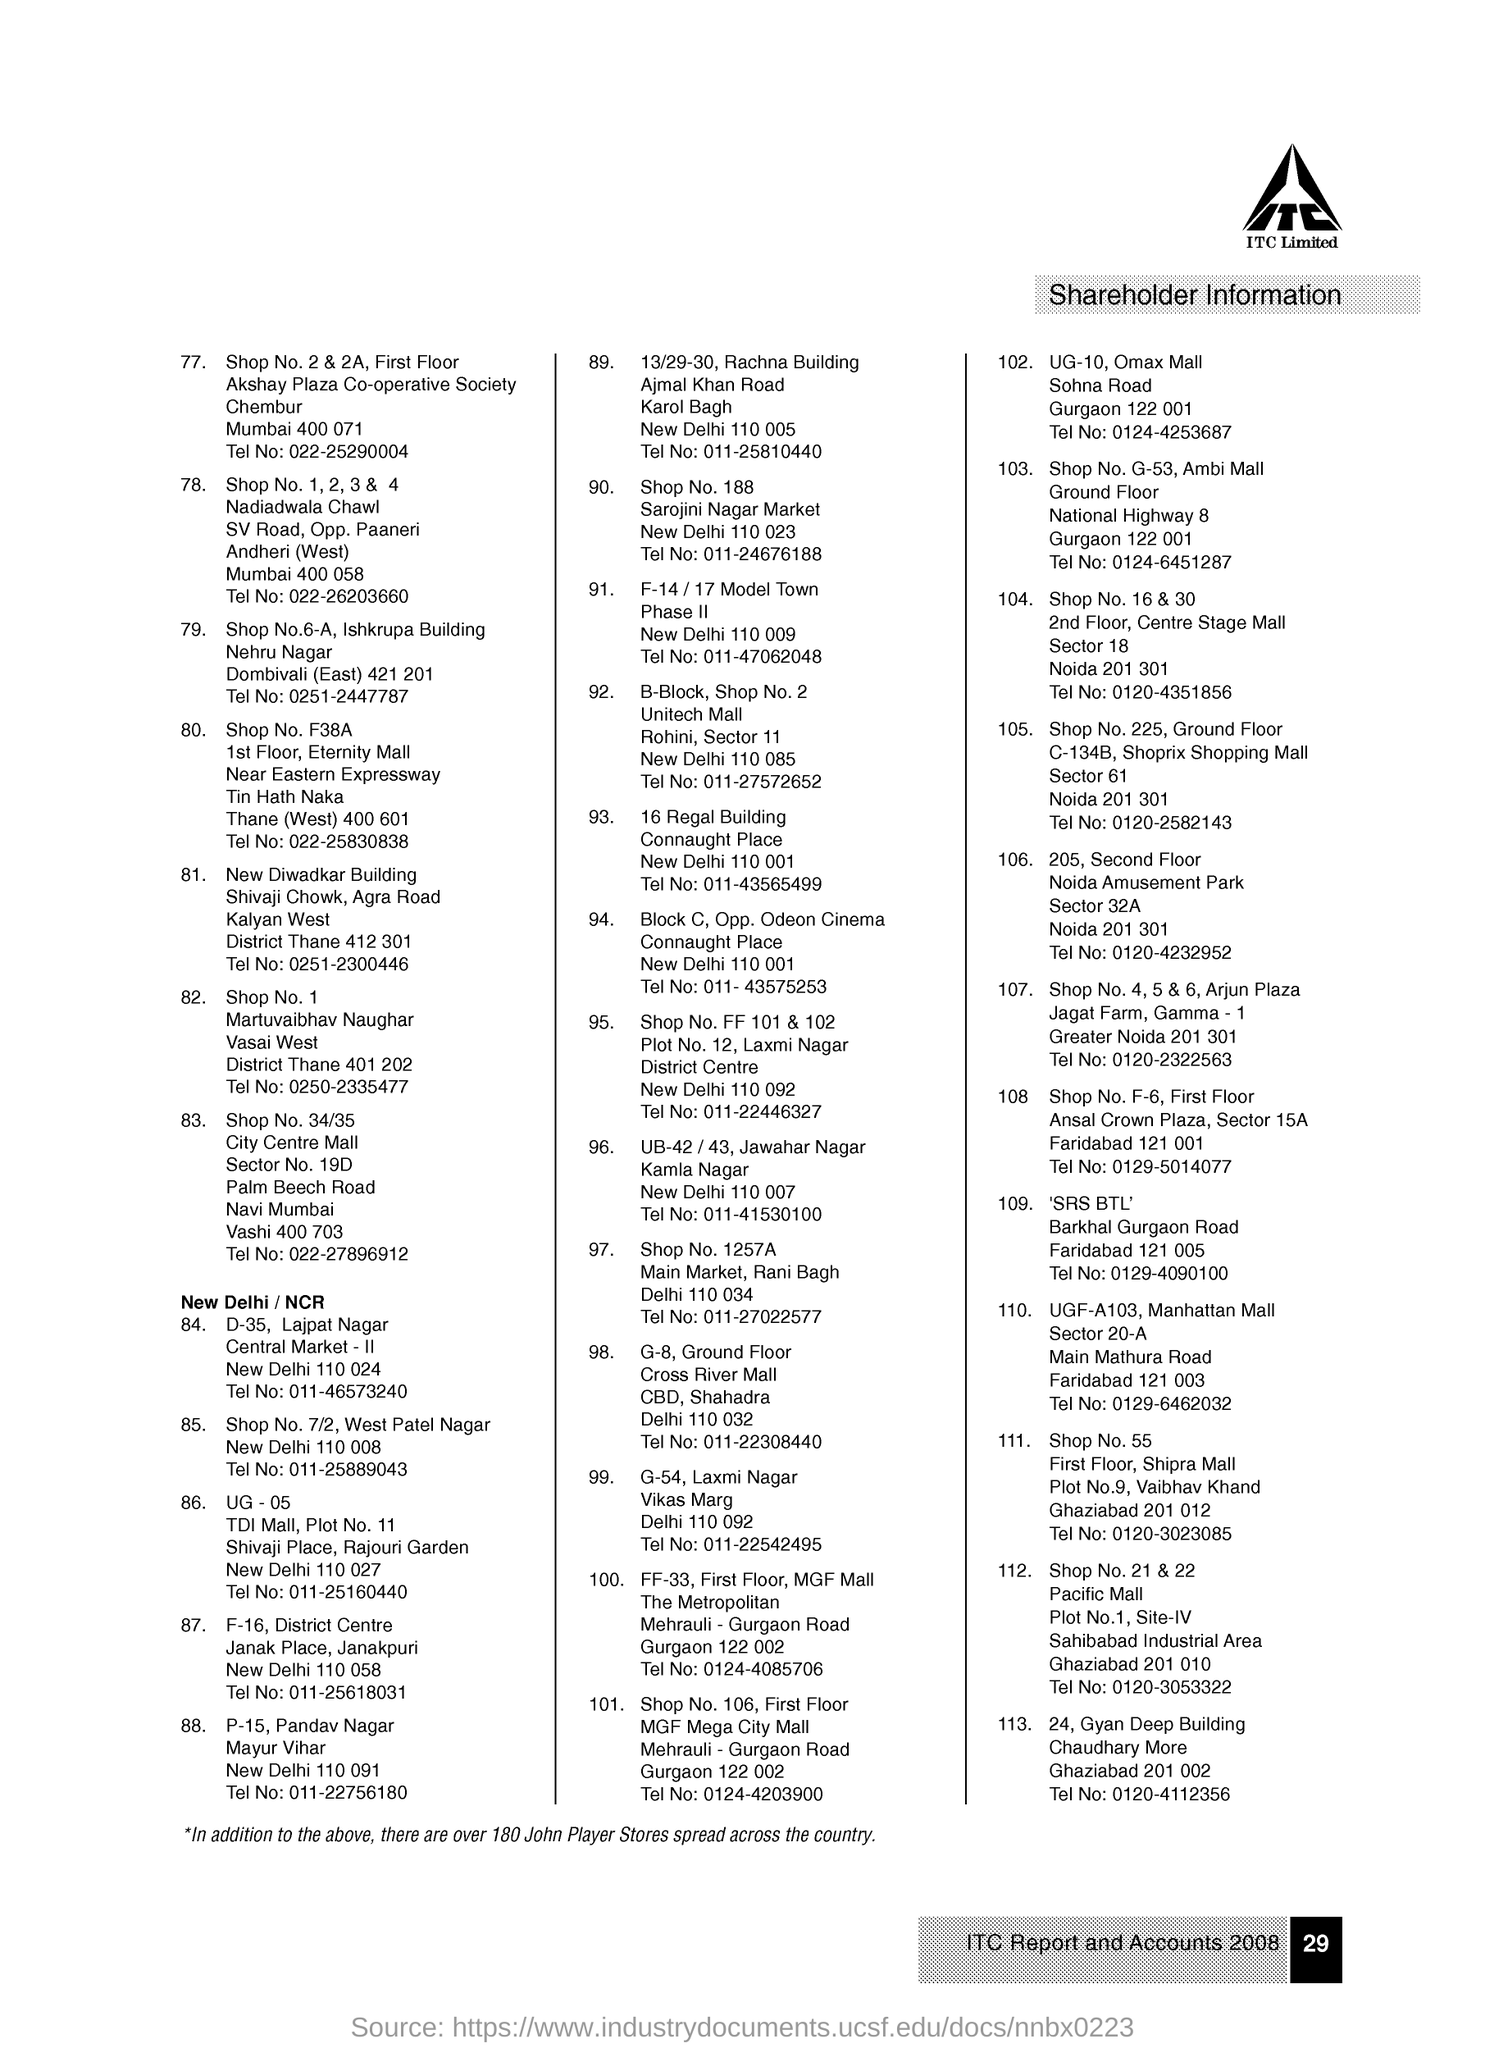What is the document about?
Keep it short and to the point. Shareholder information. What is the page number on this document?
Ensure brevity in your answer.  29. Which company's name is mentioned?
Your response must be concise. ITC Limited. 